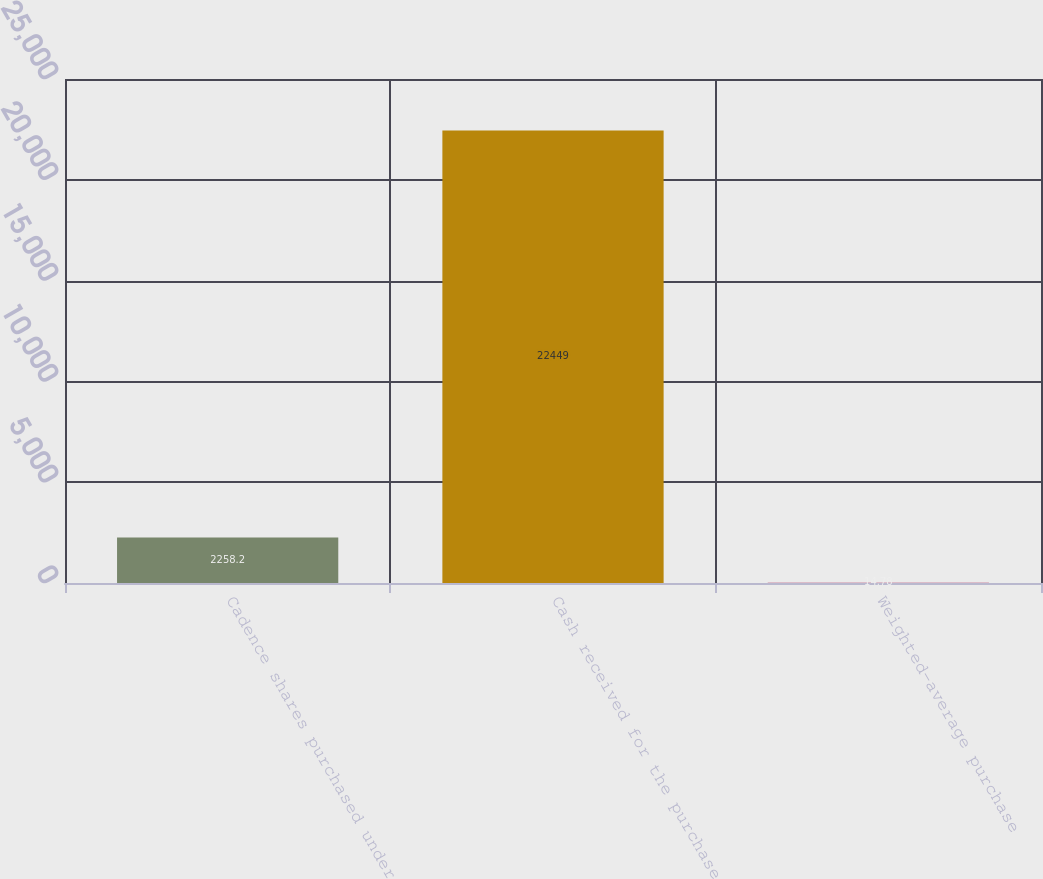<chart> <loc_0><loc_0><loc_500><loc_500><bar_chart><fcel>Cadence shares purchased under<fcel>Cash received for the purchase<fcel>Weighted-average purchase<nl><fcel>2258.2<fcel>22449<fcel>14.78<nl></chart> 